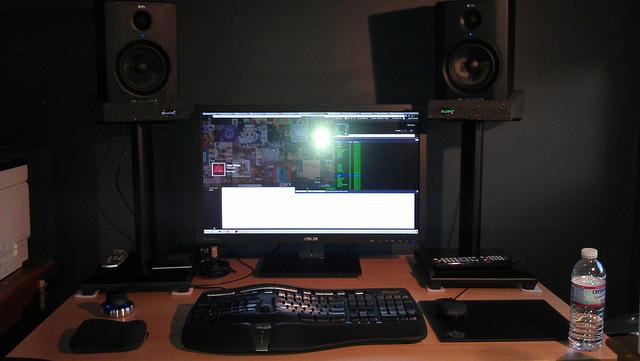Are they watching a movie?
Write a very short answer. No. What are they drinking?
Quick response, please. Water. Is this a TV or a computer?
Answer briefly. Computer. 